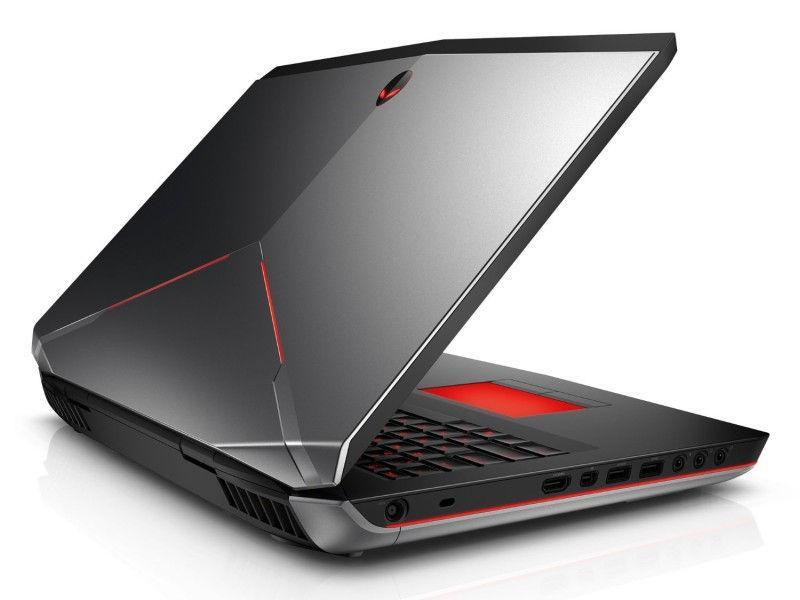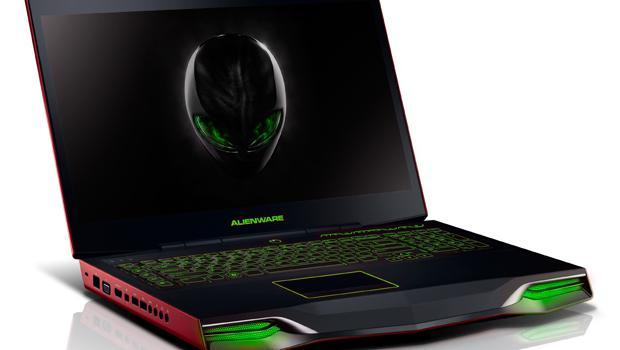The first image is the image on the left, the second image is the image on the right. Examine the images to the left and right. Is the description "The screen if visible in four laptops." accurate? Answer yes or no. No. The first image is the image on the left, the second image is the image on the right. Considering the images on both sides, is "there are two laptops fully open in the image pair" valid? Answer yes or no. No. 